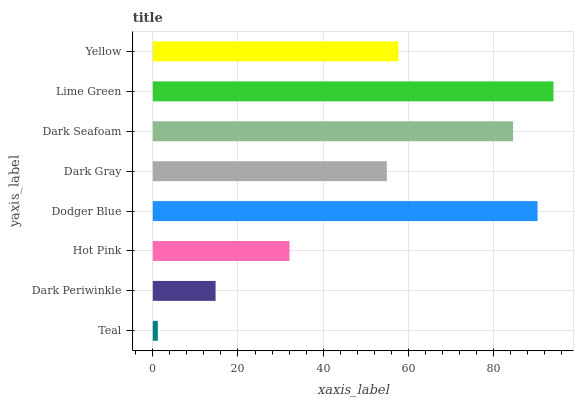Is Teal the minimum?
Answer yes or no. Yes. Is Lime Green the maximum?
Answer yes or no. Yes. Is Dark Periwinkle the minimum?
Answer yes or no. No. Is Dark Periwinkle the maximum?
Answer yes or no. No. Is Dark Periwinkle greater than Teal?
Answer yes or no. Yes. Is Teal less than Dark Periwinkle?
Answer yes or no. Yes. Is Teal greater than Dark Periwinkle?
Answer yes or no. No. Is Dark Periwinkle less than Teal?
Answer yes or no. No. Is Yellow the high median?
Answer yes or no. Yes. Is Dark Gray the low median?
Answer yes or no. Yes. Is Teal the high median?
Answer yes or no. No. Is Lime Green the low median?
Answer yes or no. No. 